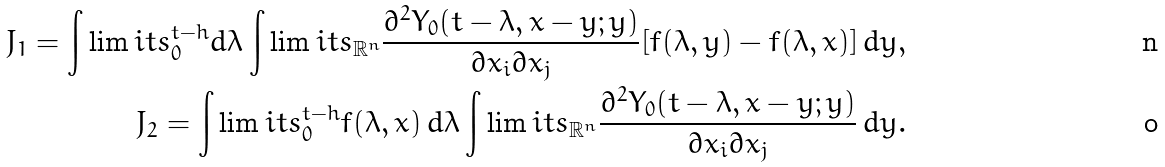Convert formula to latex. <formula><loc_0><loc_0><loc_500><loc_500>J _ { 1 } = \int \lim i t s _ { 0 } ^ { t - h } d \lambda \int \lim i t s _ { \mathbb { R } ^ { n } } \frac { \partial ^ { 2 } Y _ { 0 } ( t - \lambda , x - y ; y ) } { \partial x _ { i } \partial x _ { j } } [ f ( \lambda , y ) - f ( \lambda , x ) ] \, d y , \\ J _ { 2 } = \int \lim i t s _ { 0 } ^ { t - h } f ( \lambda , x ) \, d \lambda \int \lim i t s _ { \mathbb { R } ^ { n } } \frac { \partial ^ { 2 } Y _ { 0 } ( t - \lambda , x - y ; y ) } { \partial x _ { i } \partial x _ { j } } \, d y .</formula> 